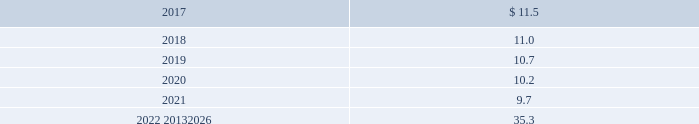Apply as it has no impact on plan obligations .
For 2015 , the healthcare trend rate was 7% ( 7 % ) , the ultimate trend rate was 5% ( 5 % ) , and the year the ultimate trend rate is reached was 2019 .
Projected benefit payments are as follows: .
These estimated benefit payments are based on assumptions about future events .
Actual benefit payments may vary significantly from these estimates .
17 .
Commitments and contingencies litigation we are involved in various legal proceedings , including commercial , competition , environmental , health , safety , product liability , and insurance matters .
In september 2010 , the brazilian administrative council for economic defense ( cade ) issued a decision against our brazilian subsidiary , air products brasil ltda. , and several other brazilian industrial gas companies for alleged anticompetitive activities .
Cade imposed a civil fine of r$ 179.2 million ( approximately $ 55 at 30 september 2016 ) on air products brasil ltda .
This fine was based on a recommendation by a unit of the brazilian ministry of justice , whose investigation began in 2003 , alleging violation of competition laws with respect to the sale of industrial and medical gases .
The fines are based on a percentage of our total revenue in brazil in 2003 .
We have denied the allegations made by the authorities and filed an appeal in october 2010 with the brazilian courts .
On 6 may 2014 , our appeal was granted and the fine against air products brasil ltda .
Was dismissed .
Cade has appealed that ruling and the matter remains pending .
We , with advice of our outside legal counsel , have assessed the status of this matter and have concluded that , although an adverse final judgment after exhausting all appeals is possible , such a judgment is not probable .
As a result , no provision has been made in the consolidated financial statements .
We estimate the maximum possible loss to be the full amount of the fine of r$ 179.2 million ( approximately $ 55 at 30 september 2016 ) plus interest accrued thereon until final disposition of the proceedings .
Other than this matter , we do not currently believe there are any legal proceedings , individually or in the aggregate , that are reasonably possible to have a material impact on our financial condition , results of operations , or cash flows .
Environmental in the normal course of business , we are involved in legal proceedings under the comprehensive environmental response , compensation , and liability act ( cercla : the federal superfund law ) ; resource conservation and recovery act ( rcra ) ; and similar state and foreign environmental laws relating to the designation of certain sites for investigation or remediation .
Presently , there are approximately 33 sites on which a final settlement has not been reached where we , along with others , have been designated a potentially responsible party by the environmental protection agency or are otherwise engaged in investigation or remediation , including cleanup activity at certain of our current and former manufacturing sites .
We continually monitor these sites for which we have environmental exposure .
Accruals for environmental loss contingencies are recorded when it is probable that a liability has been incurred and the amount of loss can be reasonably estimated .
The consolidated balance sheets at 30 september 2016 and 2015 included an accrual of $ 81.4 and $ 80.6 , respectively , primarily as part of other noncurrent liabilities .
The environmental liabilities will be paid over a period of up to 30 years .
We estimate the exposure for environmental loss contingencies to range from $ 81 to a reasonably possible upper exposure of $ 95 as of 30 september 2016. .
Considering the years 2019-2020 , what was the decrease observed in the projected benefit payments? 
Rationale: it is the 2020 value of the projected benefit payment divided by the 2019's then subtracted 1 and turned into a percentage .
Computations: (((10.2 / 10.7) - 1) * 100)
Answer: -4.6729. 